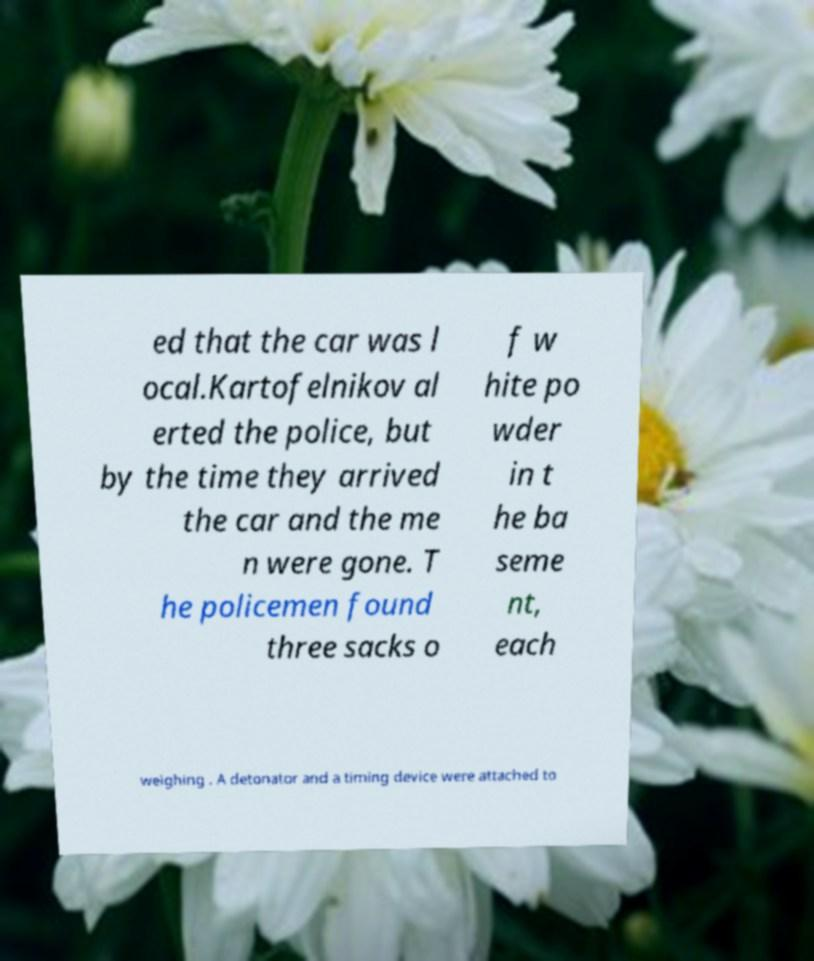There's text embedded in this image that I need extracted. Can you transcribe it verbatim? ed that the car was l ocal.Kartofelnikov al erted the police, but by the time they arrived the car and the me n were gone. T he policemen found three sacks o f w hite po wder in t he ba seme nt, each weighing . A detonator and a timing device were attached to 